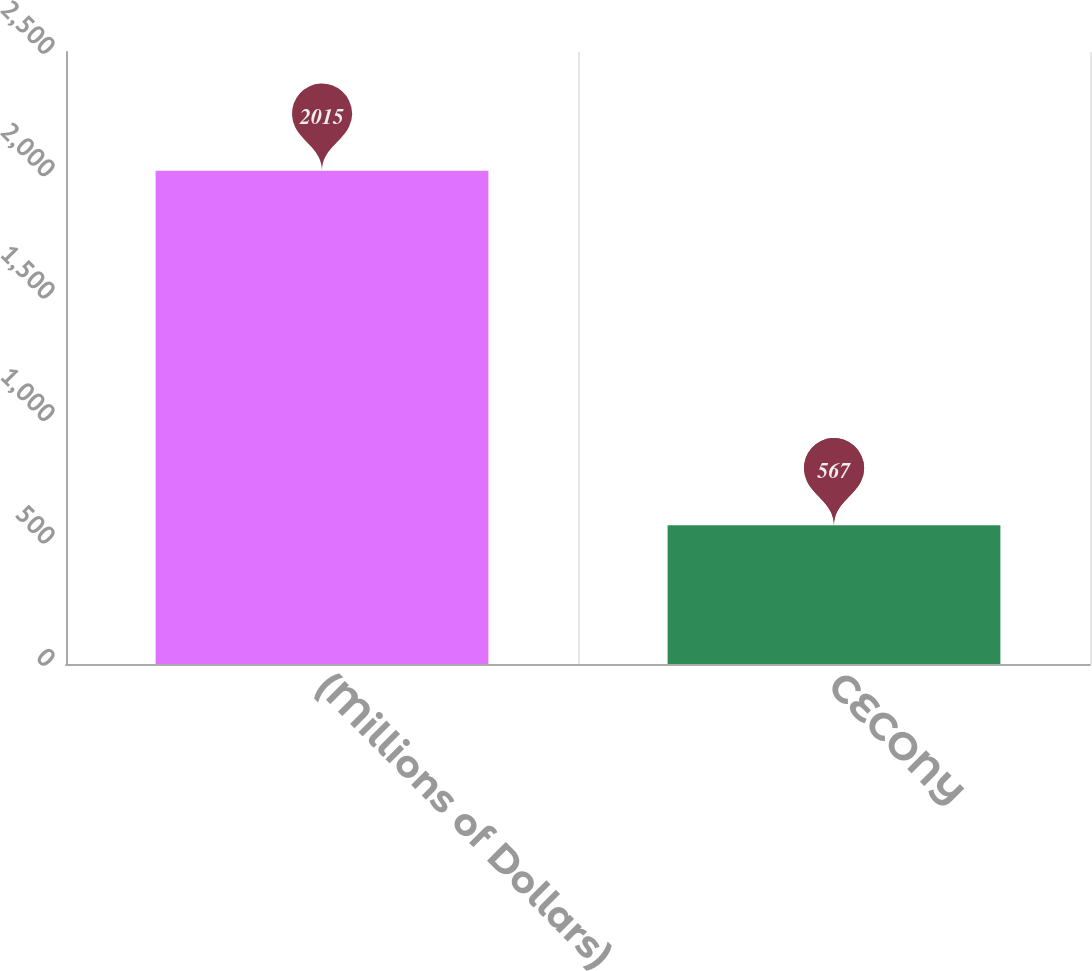<chart> <loc_0><loc_0><loc_500><loc_500><bar_chart><fcel>(Millions of Dollars)<fcel>CECONY<nl><fcel>2015<fcel>567<nl></chart> 